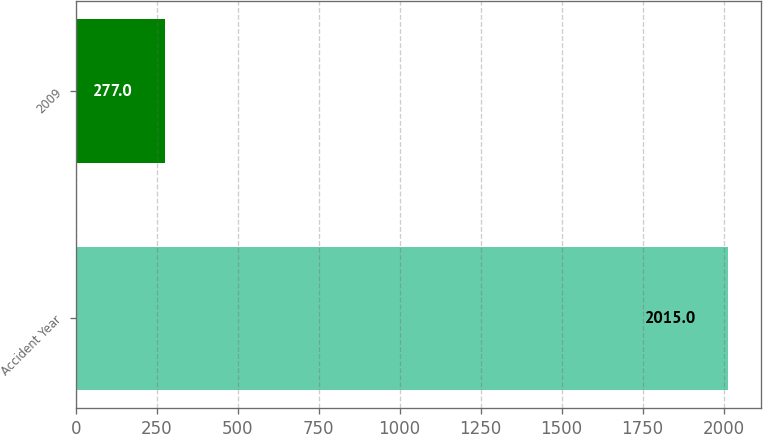<chart> <loc_0><loc_0><loc_500><loc_500><bar_chart><fcel>Accident Year<fcel>2009<nl><fcel>2015<fcel>277<nl></chart> 